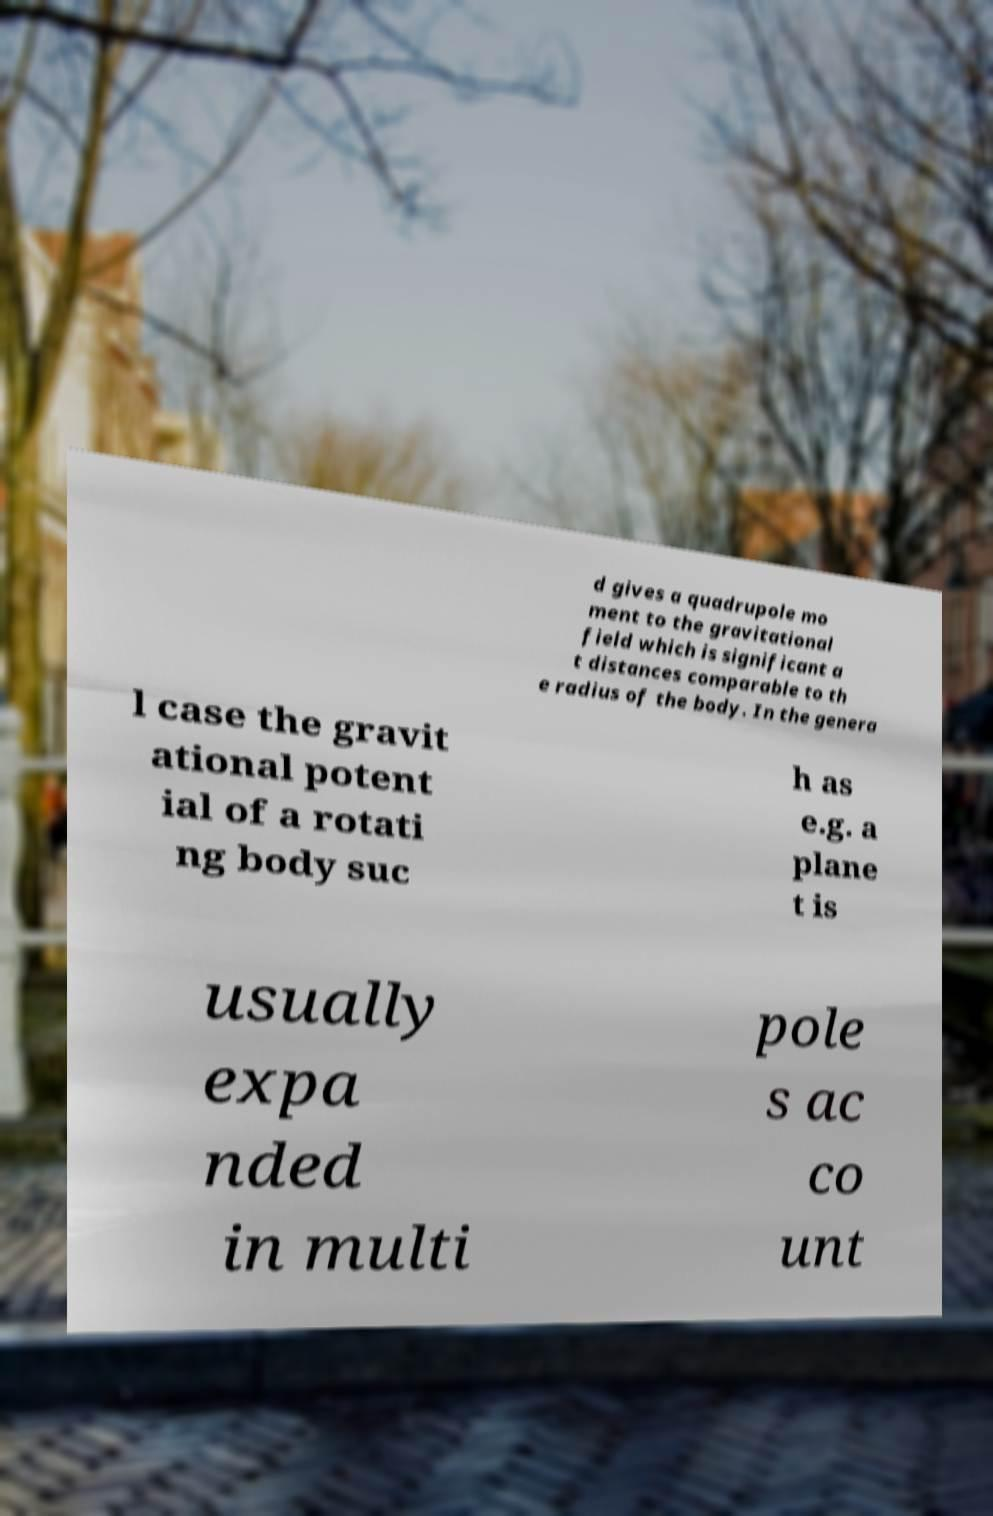Can you accurately transcribe the text from the provided image for me? d gives a quadrupole mo ment to the gravitational field which is significant a t distances comparable to th e radius of the body. In the genera l case the gravit ational potent ial of a rotati ng body suc h as e.g. a plane t is usually expa nded in multi pole s ac co unt 